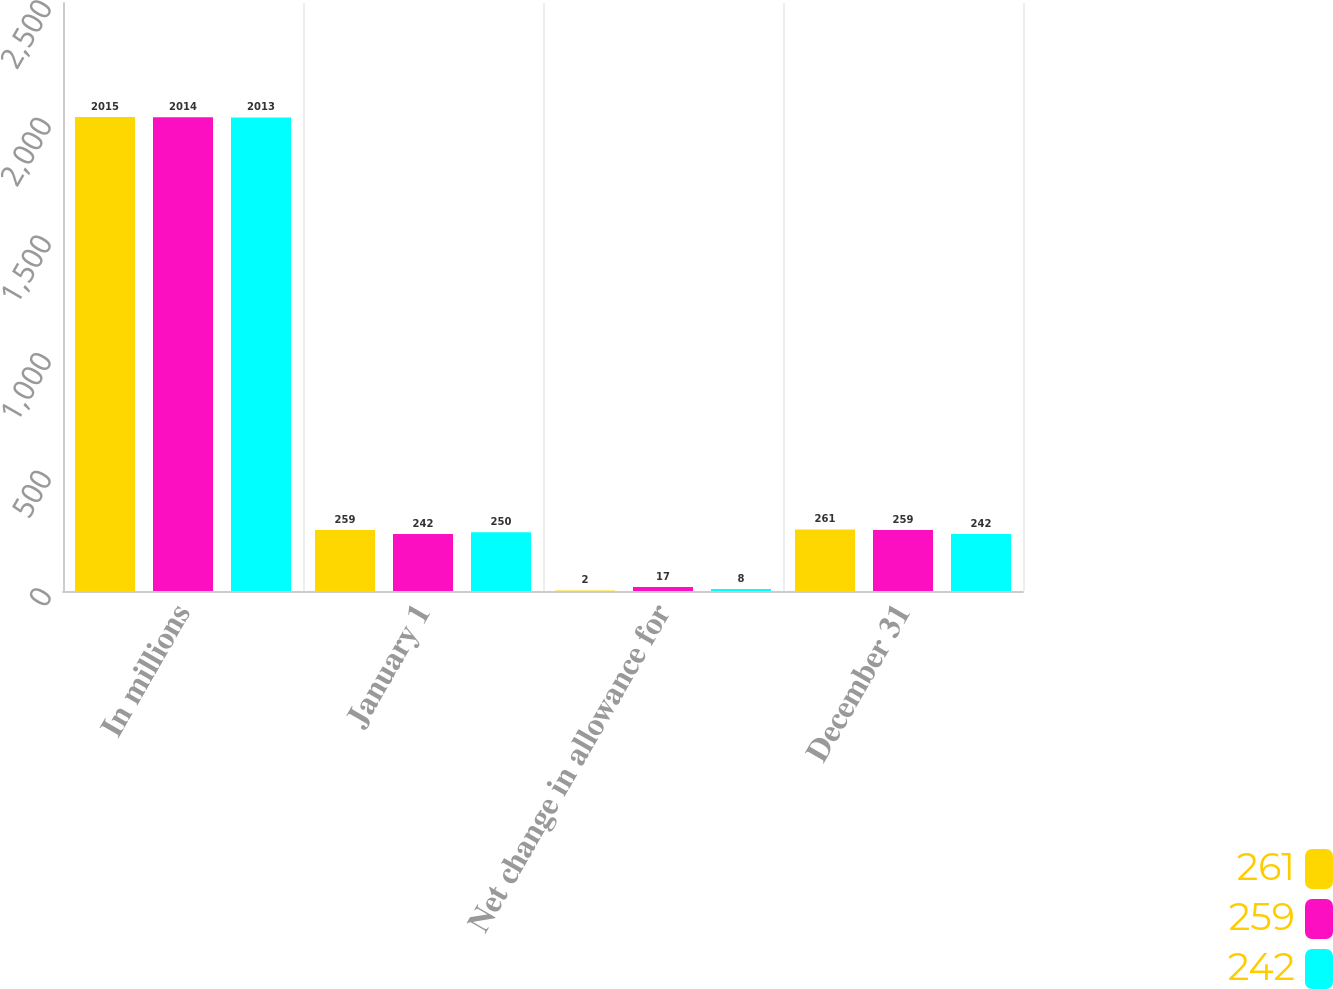Convert chart to OTSL. <chart><loc_0><loc_0><loc_500><loc_500><stacked_bar_chart><ecel><fcel>In millions<fcel>January 1<fcel>Net change in allowance for<fcel>December 31<nl><fcel>261<fcel>2015<fcel>259<fcel>2<fcel>261<nl><fcel>259<fcel>2014<fcel>242<fcel>17<fcel>259<nl><fcel>242<fcel>2013<fcel>250<fcel>8<fcel>242<nl></chart> 